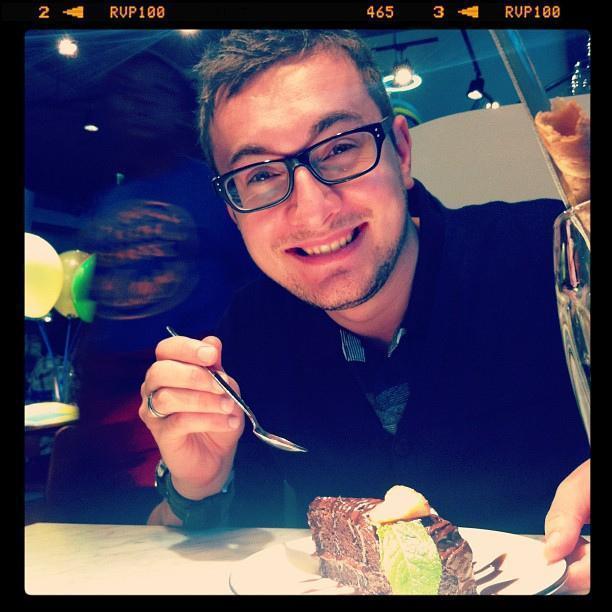Does the description: "The person is behind the cake." accurately reflect the image?
Answer yes or no. Yes. 